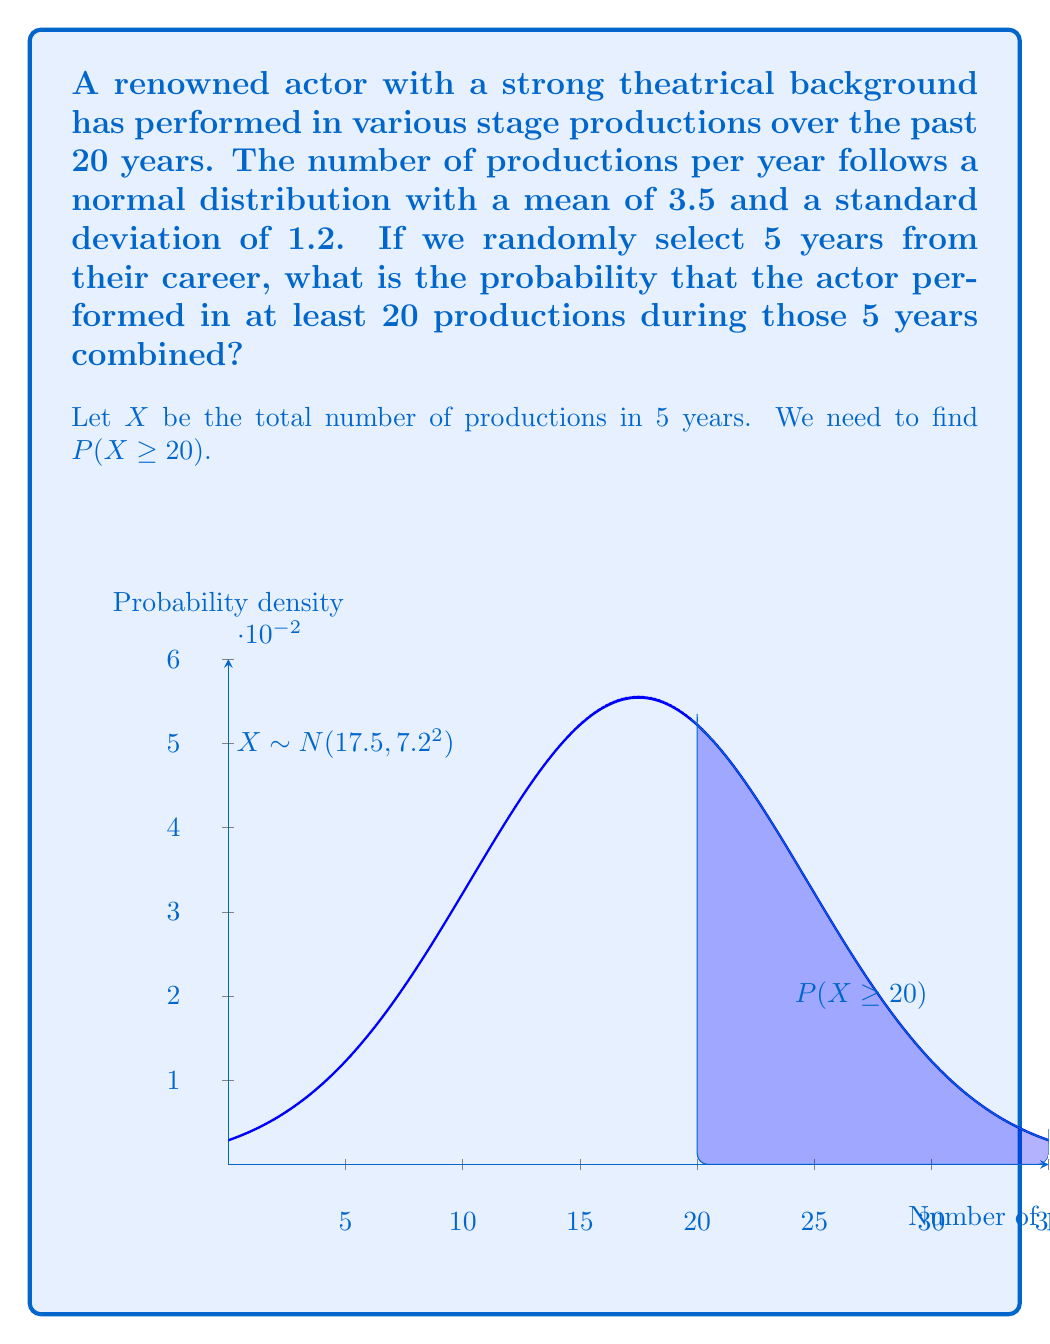Can you solve this math problem? Let's approach this step-by-step:

1) First, we need to determine the distribution of X (total productions in 5 years):
   
   - For each year, the number of productions follows N(3.5, 1.2²)
   - For 5 years, we sum 5 independent normal distributions
   - The sum of independent normal distributions is also normal
   
2) The mean of X:
   $$\mu_X = 5 \times 3.5 = 17.5$$

3) The variance of X:
   $$\sigma_X^2 = 5 \times 1.2^2 = 7.2$$

4) So, X follows N(17.5, 7.2²)

5) We want to find P(X ≥ 20). To use the standard normal distribution, we need to standardize:

   $$Z = \frac{X - \mu_X}{\sigma_X} = \frac{20 - 17.5}{7.2} \approx 0.3472$$

6) Now we need to find P(Z ≥ 0.3472)

7) Using a standard normal table or calculator:
   
   P(Z ≥ 0.3472) = 1 - P(Z < 0.3472) ≈ 1 - 0.6358 ≈ 0.3642

Therefore, the probability that the actor performed in at least 20 productions during those 5 years is approximately 0.3642 or 36.42%.
Answer: 0.3642 